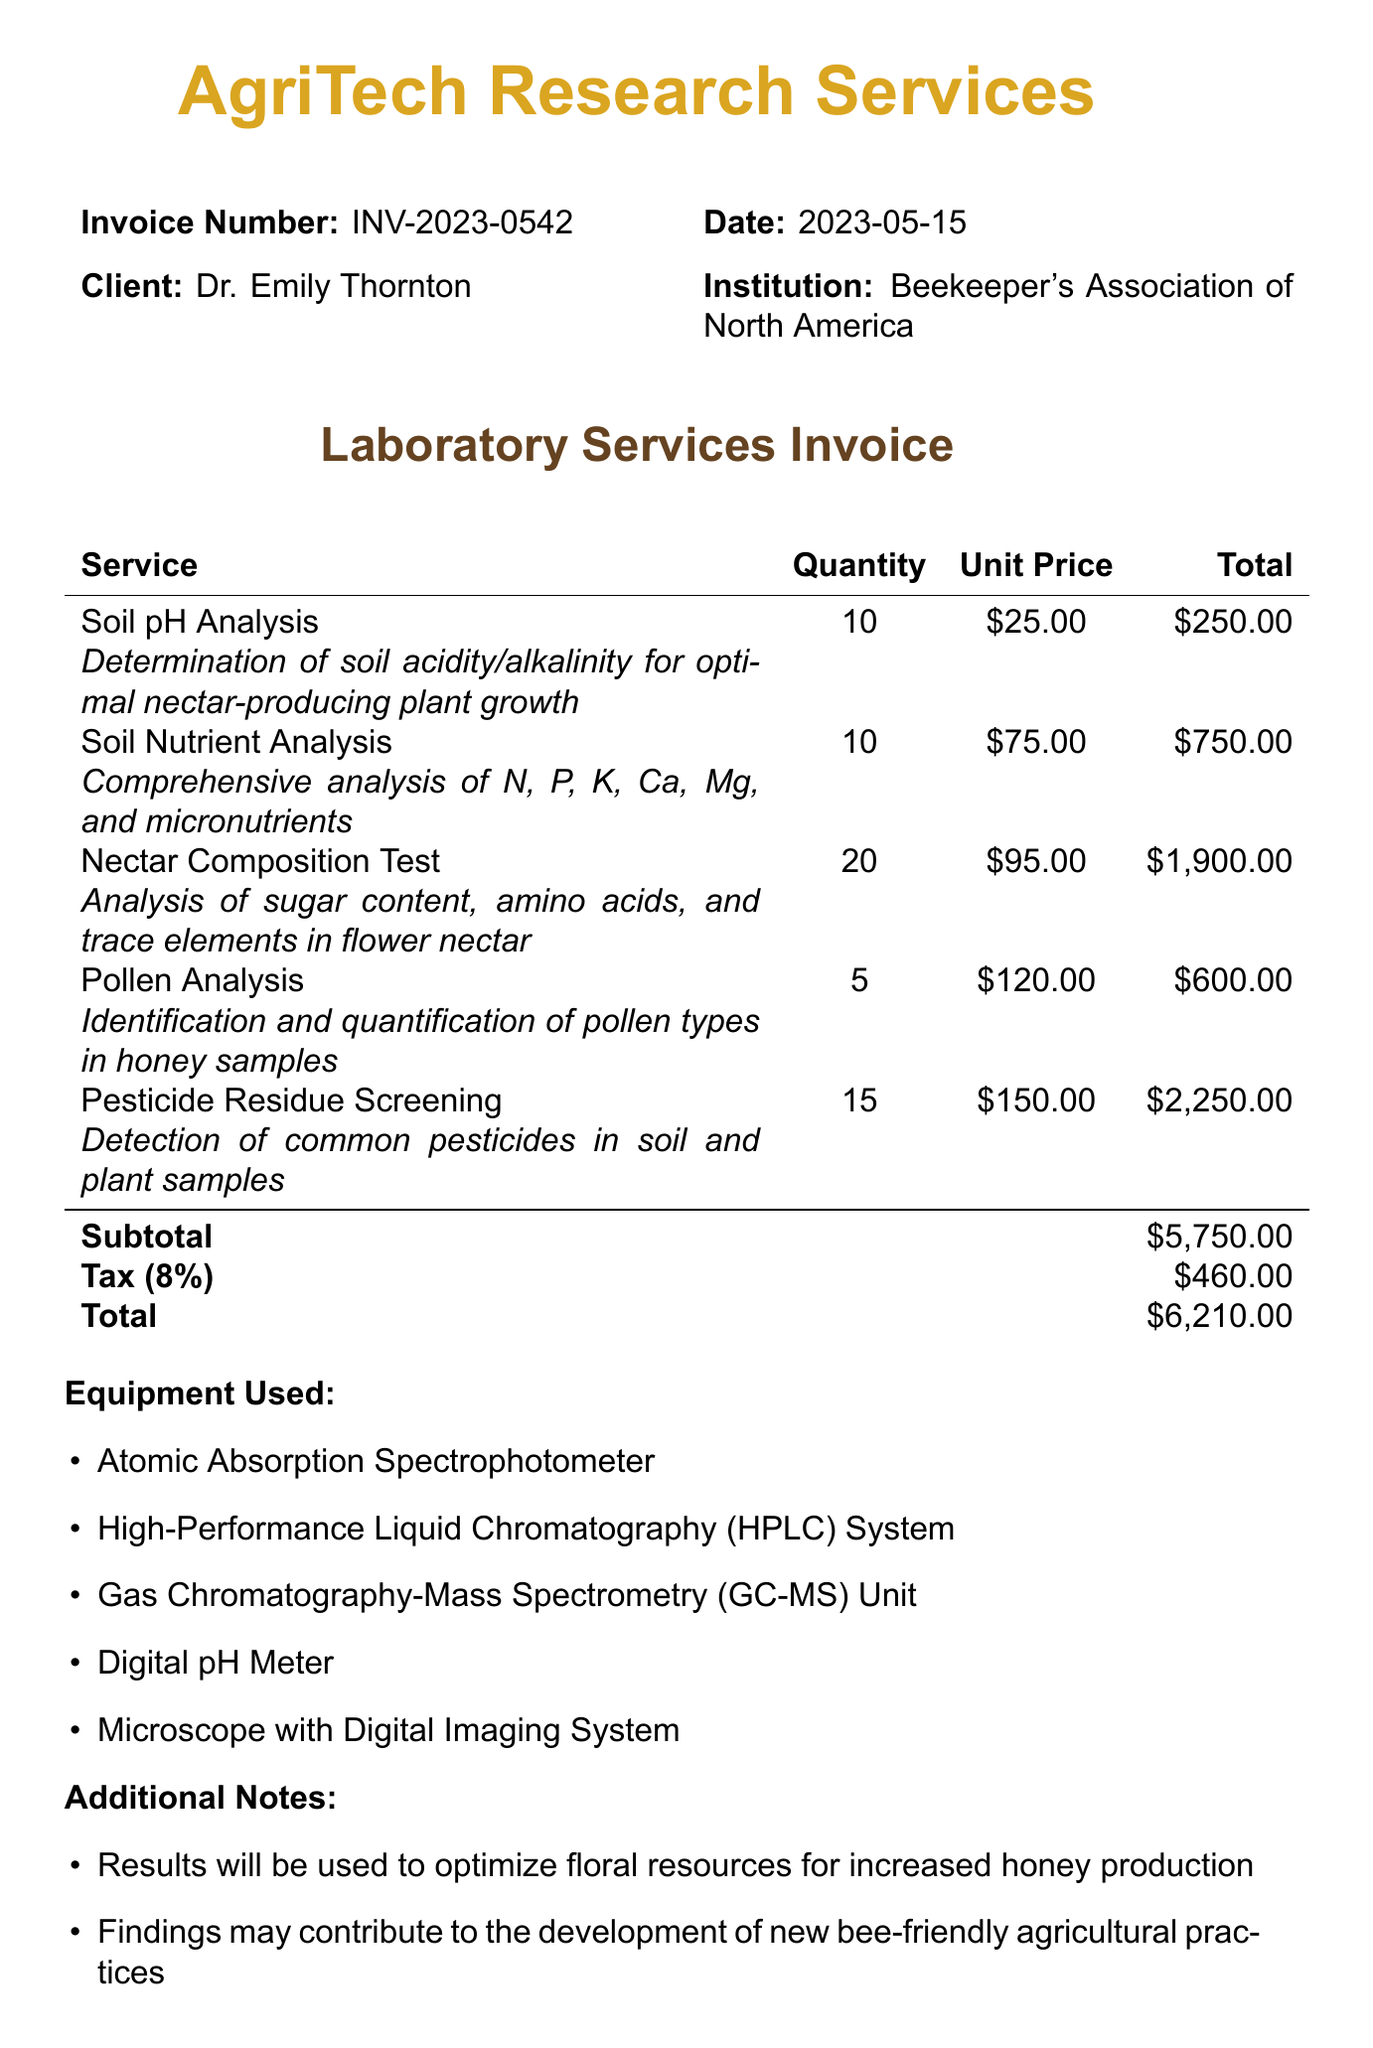What is the name of the laboratory? The name of the laboratory is listed at the top of the document.
Answer: AgriTech Research Services What is the invoice number? The invoice number is explicitly stated in the document.
Answer: INV-2023-0542 What is the date of the invoice? The date of the invoice is mentioned in the header section.
Answer: 2023-05-15 How many Nectar Composition Tests were conducted? The document specifies the quantity of each service provided, including Nectar Composition Tests.
Answer: 20 What is the total amount due? The total amount is summarized at the end of the document, after adding subtotal and tax.
Answer: $6,210.00 What is the tax rate applied? The tax rate is given in the financial summary of the invoice.
Answer: 8% What equipment was used for the analyses? The document includes a list of equipment under the section titled "Equipment Used."
Answer: Atomic Absorption Spectrophotometer, High-Performance Liquid Chromatography (HPLC) System, Gas Chromatography-Mass Spectrometry (GC-MS) Unit, Digital pH Meter, Microscope with Digital Imaging System What is one of the additional notes mentioned? The document has a section listing additional notes relevant to the research findings and goals.
Answer: Results will be used to optimize floral resources for increased honey production What are the payment methods accepted? The accepted payment methods are indicated towards the end of the document.
Answer: Bank transfer, Check, Credit card (Visa, MasterCard, American Express) 